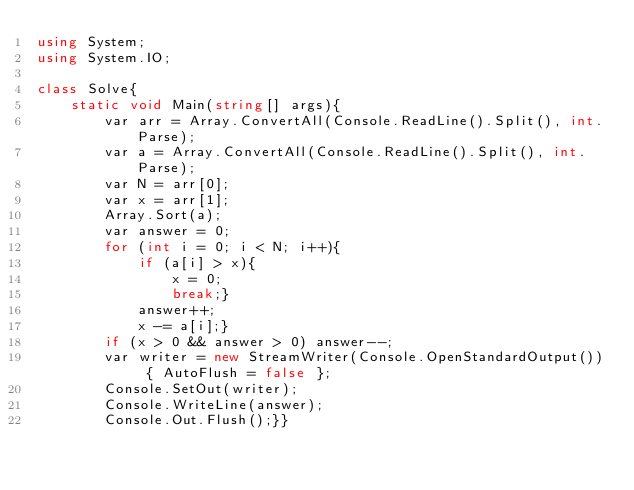Convert code to text. <code><loc_0><loc_0><loc_500><loc_500><_C#_>using System;
using System.IO;

class Solve{
    static void Main(string[] args){
        var arr = Array.ConvertAll(Console.ReadLine().Split(), int.Parse);
        var a = Array.ConvertAll(Console.ReadLine().Split(), int.Parse);
        var N = arr[0];
        var x = arr[1];
        Array.Sort(a);
        var answer = 0;
        for (int i = 0; i < N; i++){
            if (a[i] > x){
                x = 0;
                break;}
            answer++;
            x -= a[i];}
        if (x > 0 && answer > 0) answer--;
        var writer = new StreamWriter(Console.OpenStandardOutput()) { AutoFlush = false };
        Console.SetOut(writer);
        Console.WriteLine(answer);
        Console.Out.Flush();}}</code> 